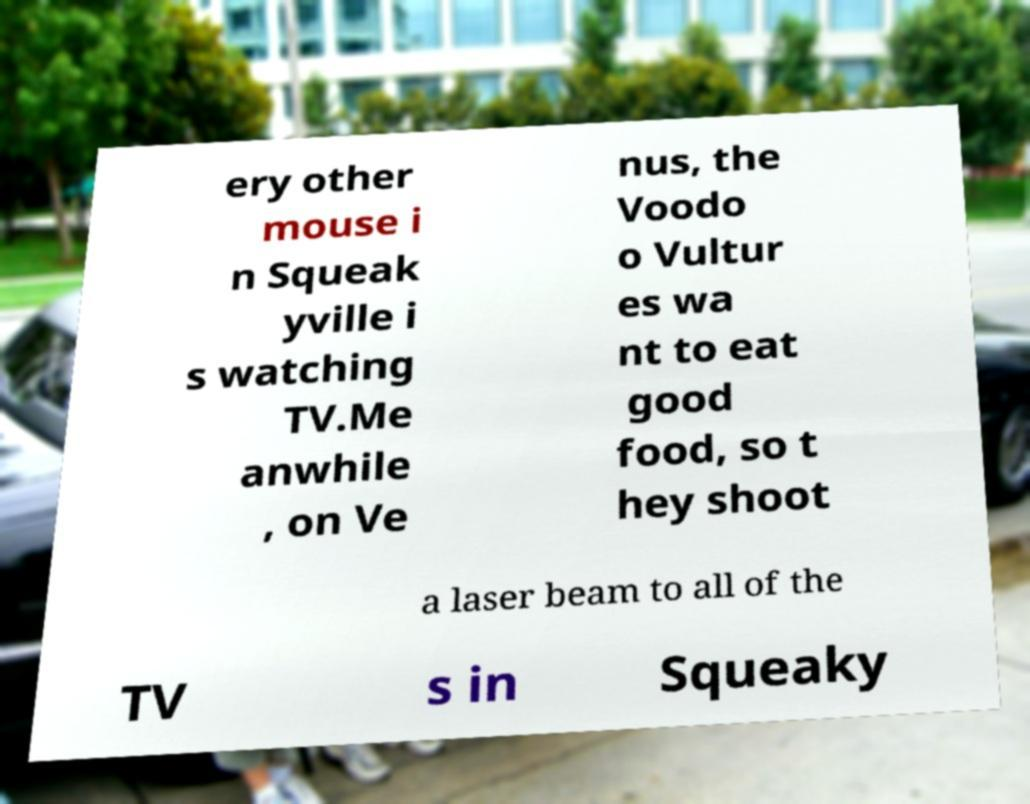Please identify and transcribe the text found in this image. ery other mouse i n Squeak yville i s watching TV.Me anwhile , on Ve nus, the Voodo o Vultur es wa nt to eat good food, so t hey shoot a laser beam to all of the TV s in Squeaky 